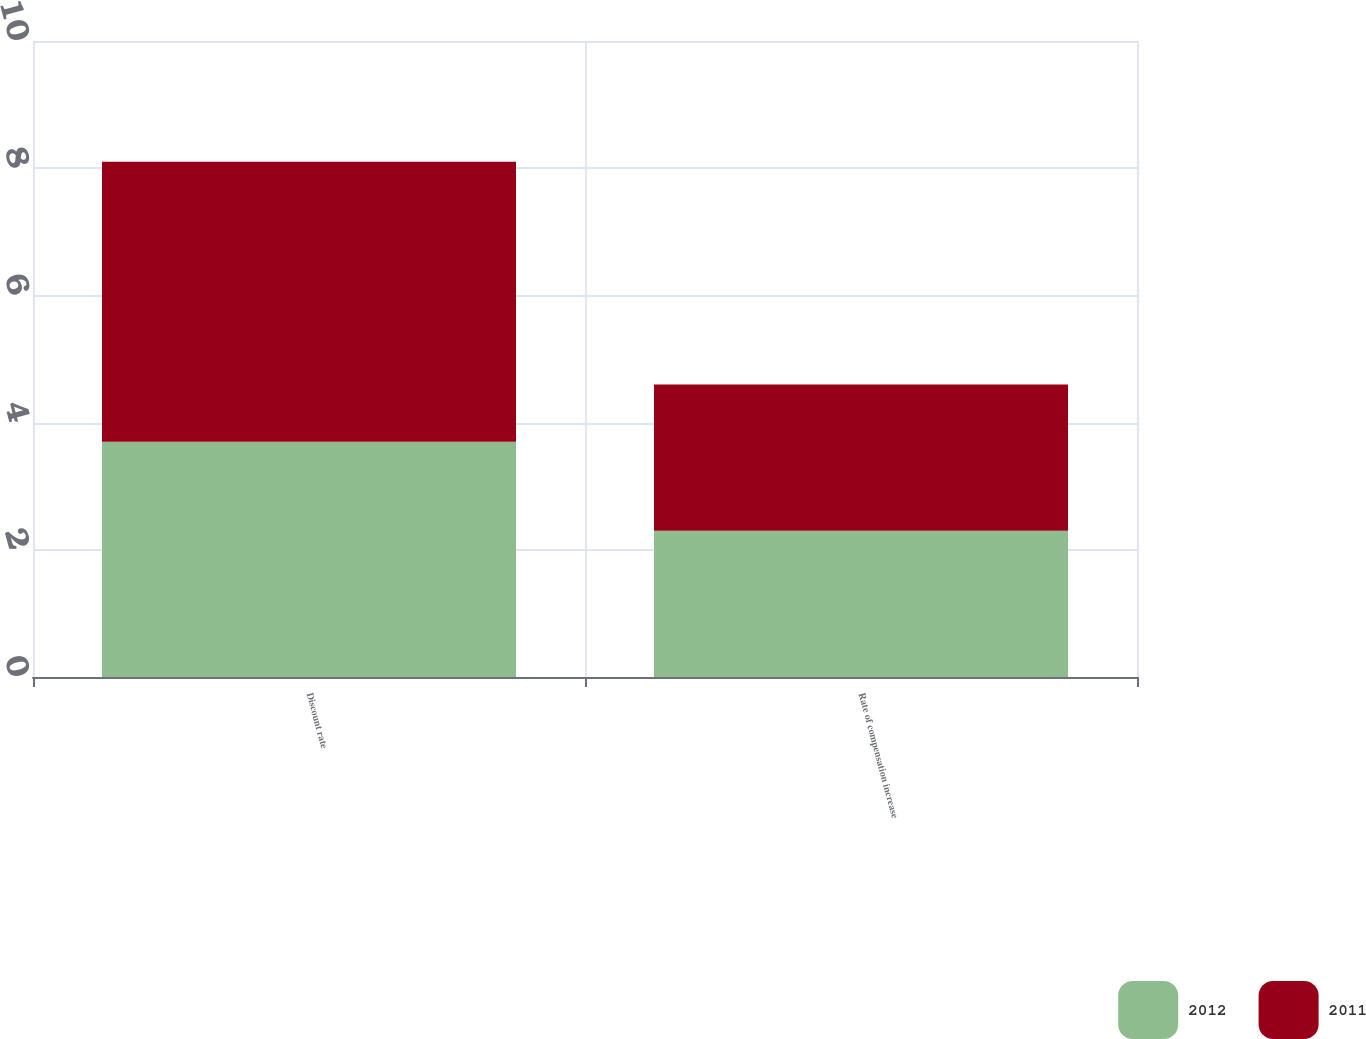Convert chart. <chart><loc_0><loc_0><loc_500><loc_500><stacked_bar_chart><ecel><fcel>Discount rate<fcel>Rate of compensation increase<nl><fcel>2012<fcel>3.7<fcel>2.3<nl><fcel>2011<fcel>4.4<fcel>2.3<nl></chart> 